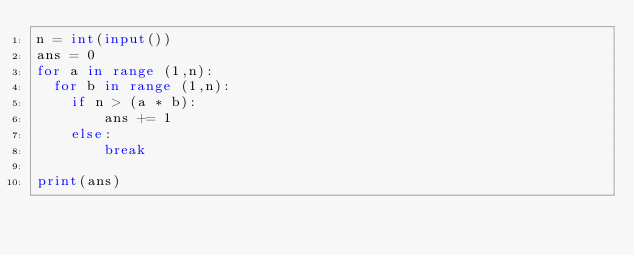Convert code to text. <code><loc_0><loc_0><loc_500><loc_500><_Python_>n = int(input())
ans = 0
for a in range (1,n):
  for b in range (1,n):
    if n > (a * b):
        ans += 1
    else:
        break

print(ans)</code> 